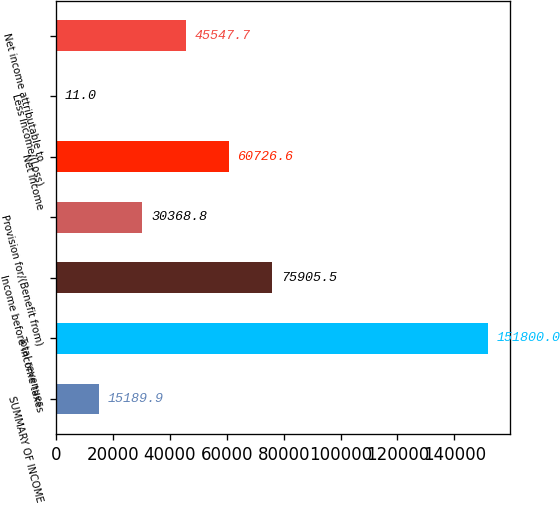Convert chart to OTSL. <chart><loc_0><loc_0><loc_500><loc_500><bar_chart><fcel>SUMMARY OF INCOME<fcel>Total revenues<fcel>Income before income taxes<fcel>Provision for/(Benefit from)<fcel>Net income<fcel>Less Income/(Loss)<fcel>Net income attributable to<nl><fcel>15189.9<fcel>151800<fcel>75905.5<fcel>30368.8<fcel>60726.6<fcel>11<fcel>45547.7<nl></chart> 